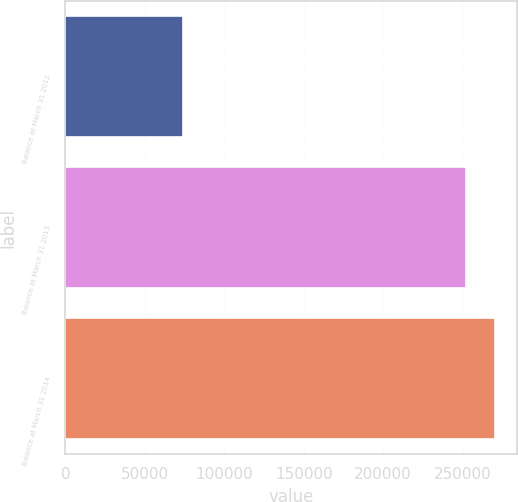<chart> <loc_0><loc_0><loc_500><loc_500><bar_chart><fcel>Balance at March 31 2012<fcel>Balance at March 31 2013<fcel>Balance at March 31 2014<nl><fcel>74313<fcel>252148<fcel>270406<nl></chart> 